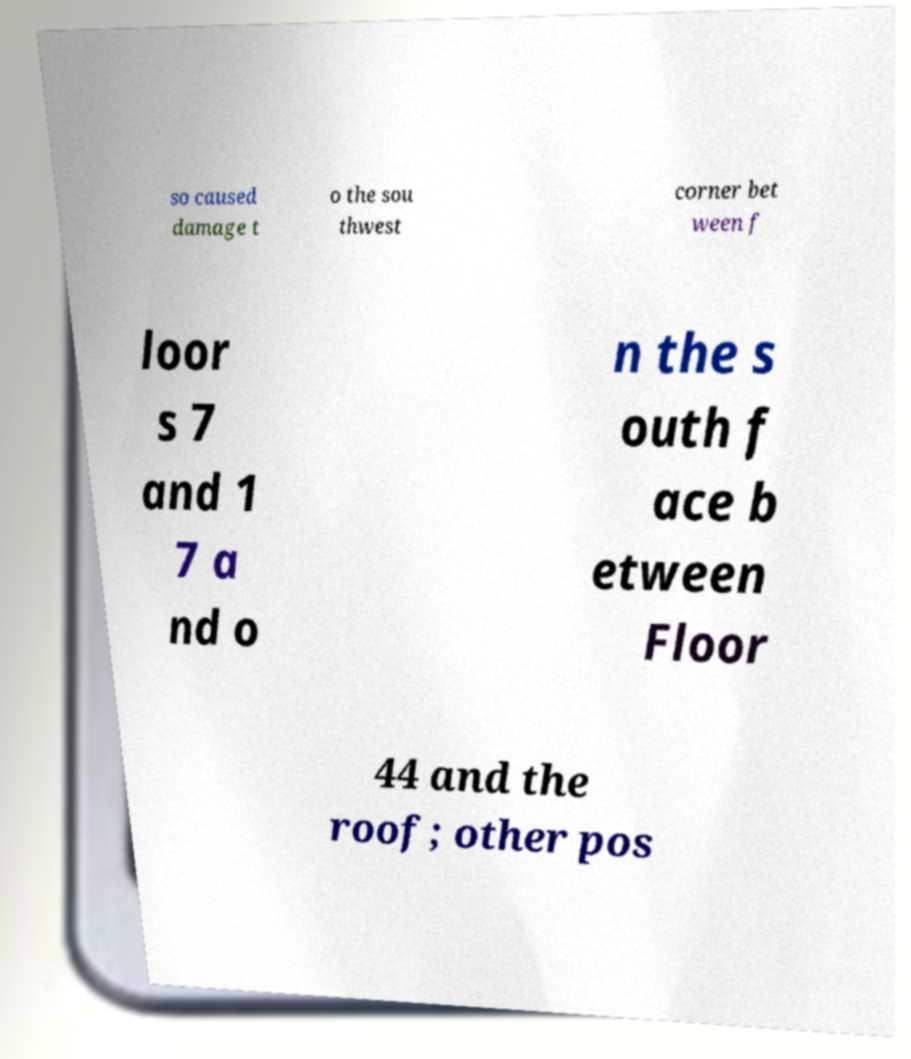Can you read and provide the text displayed in the image?This photo seems to have some interesting text. Can you extract and type it out for me? so caused damage t o the sou thwest corner bet ween f loor s 7 and 1 7 a nd o n the s outh f ace b etween Floor 44 and the roof; other pos 